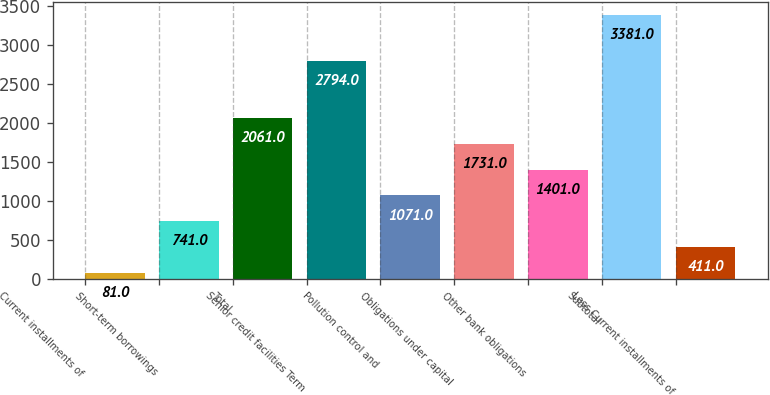Convert chart. <chart><loc_0><loc_0><loc_500><loc_500><bar_chart><fcel>Current installments of<fcel>Short-term borrowings<fcel>Total<fcel>Senior credit facilities Term<fcel>Pollution control and<fcel>Obligations under capital<fcel>Other bank obligations<fcel>Subtotal<fcel>Less Current installments of<nl><fcel>81<fcel>741<fcel>2061<fcel>2794<fcel>1071<fcel>1731<fcel>1401<fcel>3381<fcel>411<nl></chart> 